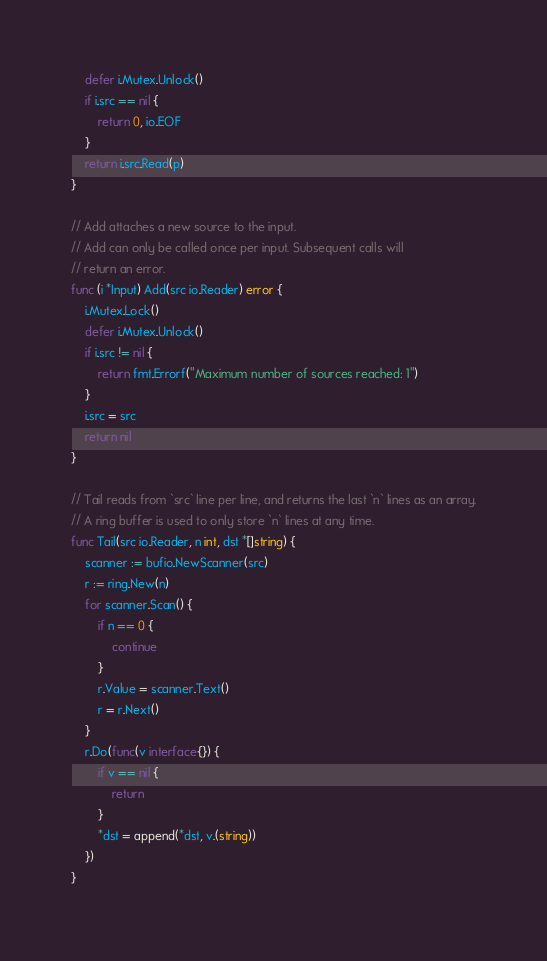<code> <loc_0><loc_0><loc_500><loc_500><_Go_>	defer i.Mutex.Unlock()
	if i.src == nil {
		return 0, io.EOF
	}
	return i.src.Read(p)
}

// Add attaches a new source to the input.
// Add can only be called once per input. Subsequent calls will
// return an error.
func (i *Input) Add(src io.Reader) error {
	i.Mutex.Lock()
	defer i.Mutex.Unlock()
	if i.src != nil {
		return fmt.Errorf("Maximum number of sources reached: 1")
	}
	i.src = src
	return nil
}

// Tail reads from `src` line per line, and returns the last `n` lines as an array.
// A ring buffer is used to only store `n` lines at any time.
func Tail(src io.Reader, n int, dst *[]string) {
	scanner := bufio.NewScanner(src)
	r := ring.New(n)
	for scanner.Scan() {
		if n == 0 {
			continue
		}
		r.Value = scanner.Text()
		r = r.Next()
	}
	r.Do(func(v interface{}) {
		if v == nil {
			return
		}
		*dst = append(*dst, v.(string))
	})
}
</code> 